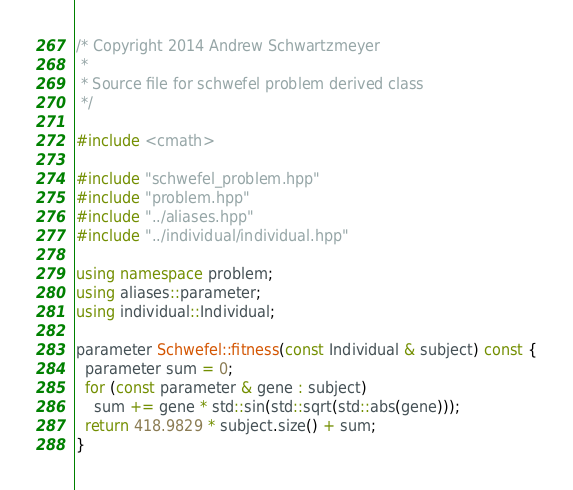Convert code to text. <code><loc_0><loc_0><loc_500><loc_500><_C++_>/* Copyright 2014 Andrew Schwartzmeyer
 *
 * Source file for schwefel problem derived class
 */

#include <cmath>

#include "schwefel_problem.hpp"
#include "problem.hpp"
#include "../aliases.hpp"
#include "../individual/individual.hpp"

using namespace problem;
using aliases::parameter;
using individual::Individual;

parameter Schwefel::fitness(const Individual & subject) const {
  parameter sum = 0;
  for (const parameter & gene : subject)
    sum += gene * std::sin(std::sqrt(std::abs(gene)));
  return 418.9829 * subject.size() + sum;
}
</code> 